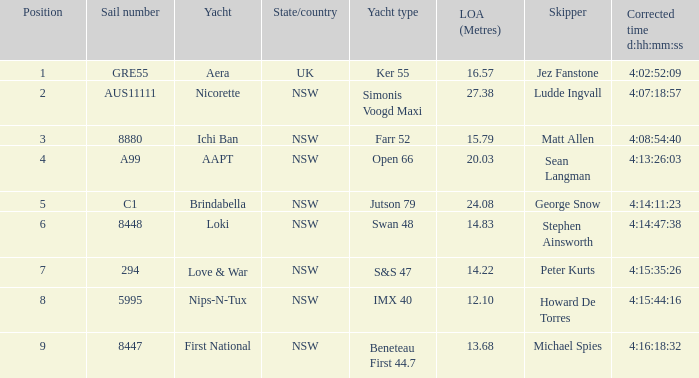What is the complete length of sail for the boat with a precise time of 4:15:35:26? 14.22. 